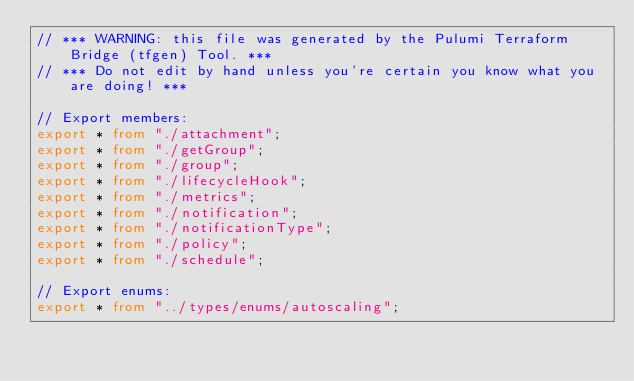<code> <loc_0><loc_0><loc_500><loc_500><_TypeScript_>// *** WARNING: this file was generated by the Pulumi Terraform Bridge (tfgen) Tool. ***
// *** Do not edit by hand unless you're certain you know what you are doing! ***

// Export members:
export * from "./attachment";
export * from "./getGroup";
export * from "./group";
export * from "./lifecycleHook";
export * from "./metrics";
export * from "./notification";
export * from "./notificationType";
export * from "./policy";
export * from "./schedule";

// Export enums:
export * from "../types/enums/autoscaling";
</code> 